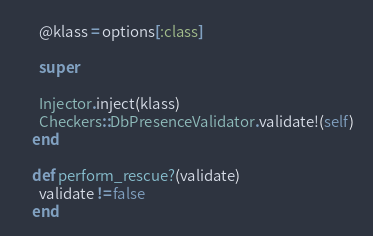Convert code to text. <code><loc_0><loc_0><loc_500><loc_500><_Ruby_>      @klass = options[:class]

      super

      Injector.inject(klass)
      Checkers::DbPresenceValidator.validate!(self)
    end

    def perform_rescue?(validate)
      validate != false
    end
</code> 